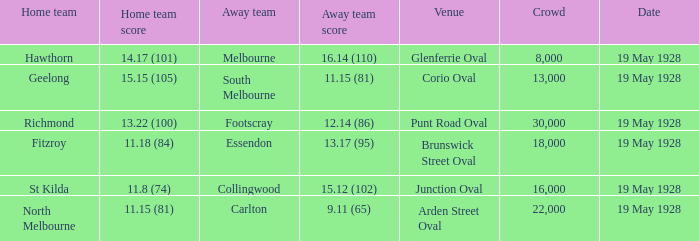What was the mentioned gathering at junction oval? 16000.0. 